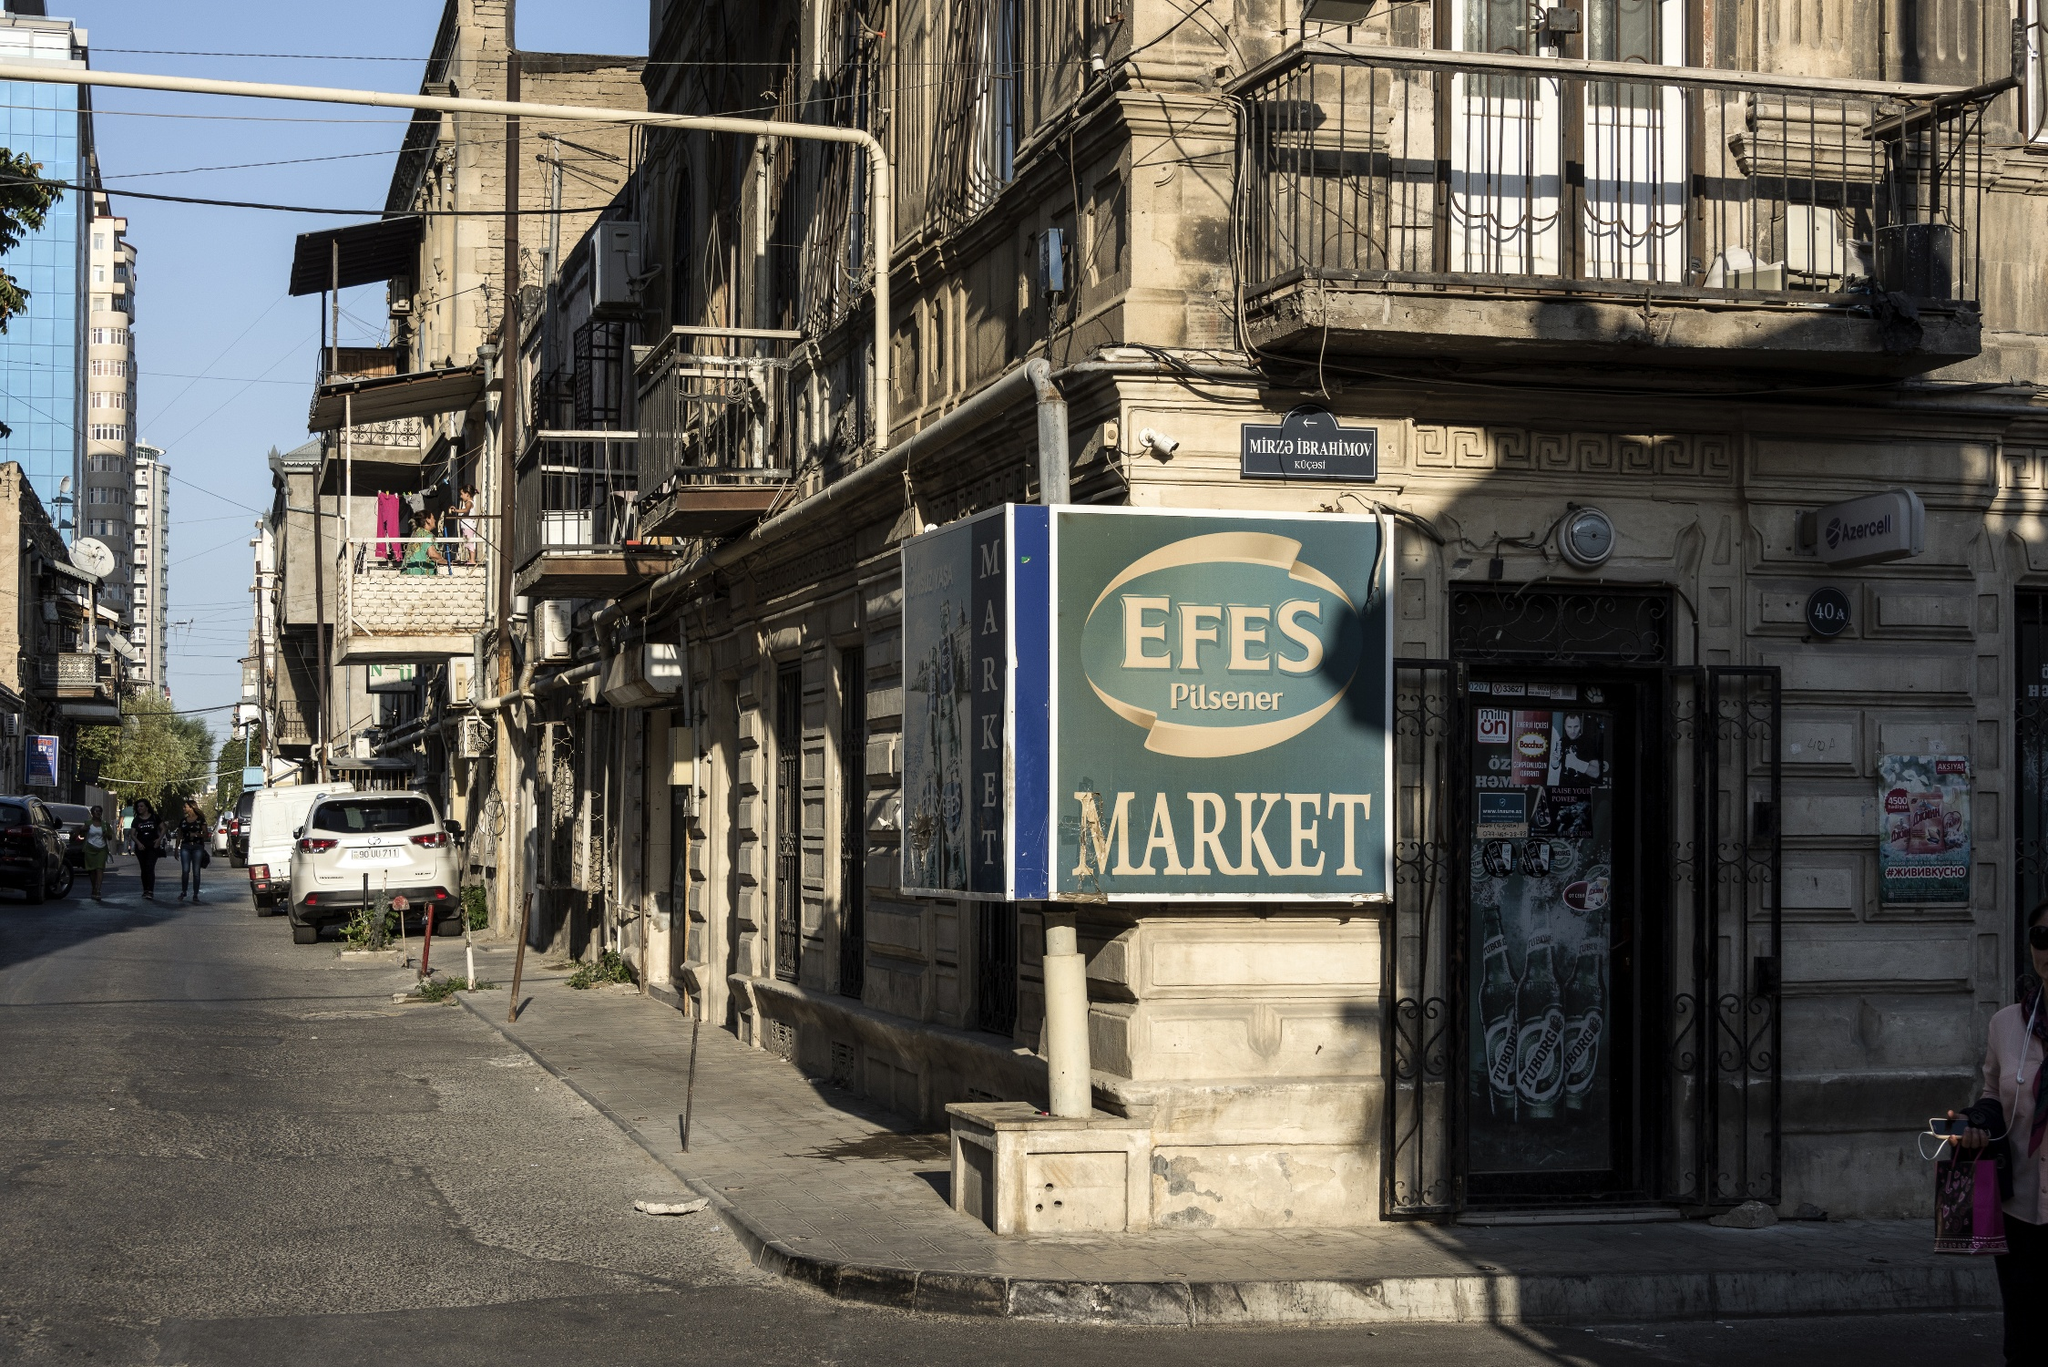Imagine a day in the life of a resident here. A day in the life of a resident in this part of Istanbul might begin early, with the sounds of street vendors setting up their stalls and the aroma of freshly baked bread wafting through the air. Residents might step out onto their balconies to greet their neighbors, a daily ritual that fosters a close-knit community. The bustling street below comes alive with the honking of cars, the chatter of pedestrians, and the distant call to prayer from a nearby mosque. Throughout the day, the market sign of EFES Pilsener stands as a meeting point for locals, who come to buy groceries, catch up on local news, and sip tea at nearby cafes. As evening falls, the vibrant hustle gently dims, replaced by the soft glow of streetlights and the silhouette of balconies against the setting sun. The day wraps up with families gathering for dinner, sharing stories of their day, and a sense of calm enveloping the neighborhood, preparing for the next day's unfolding stories. 